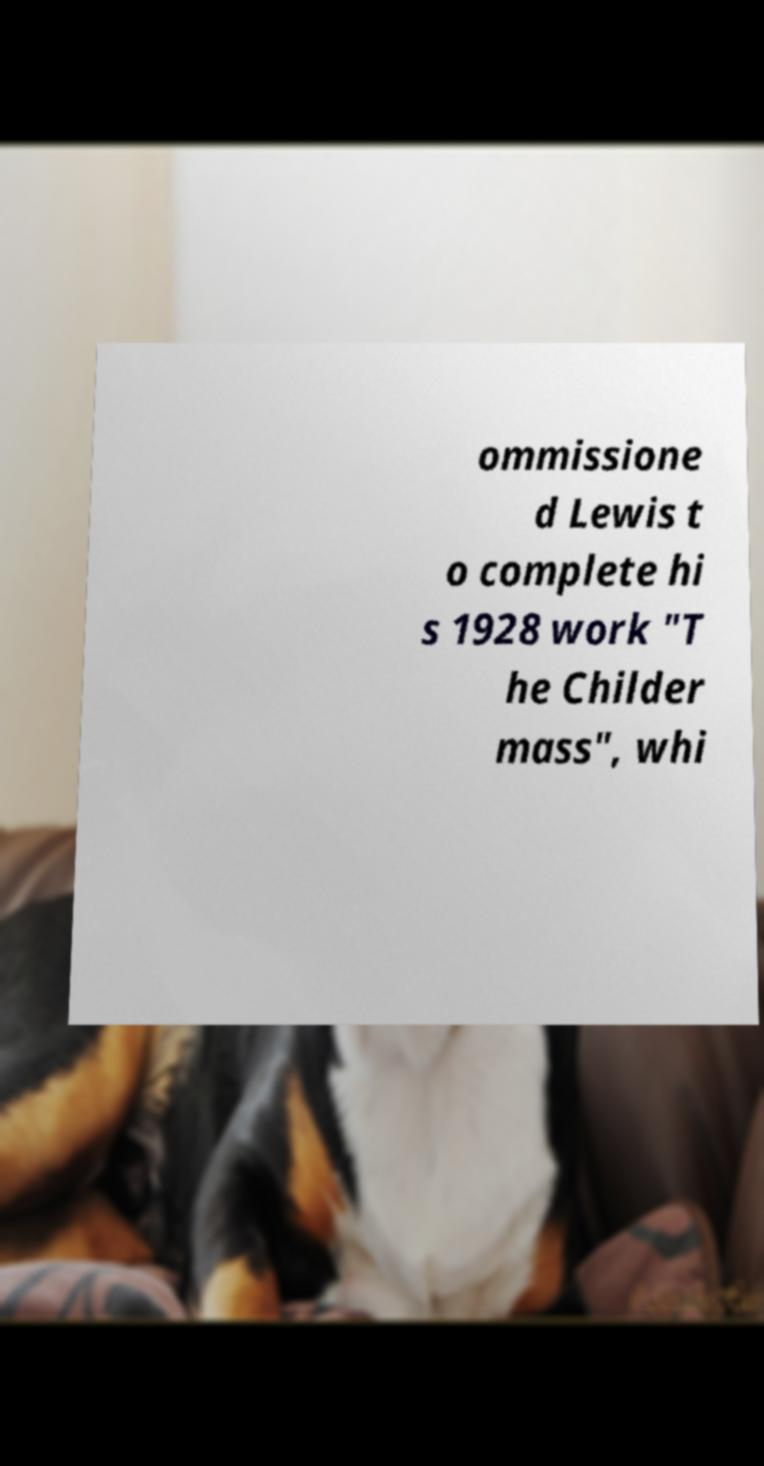Please identify and transcribe the text found in this image. ommissione d Lewis t o complete hi s 1928 work "T he Childer mass", whi 